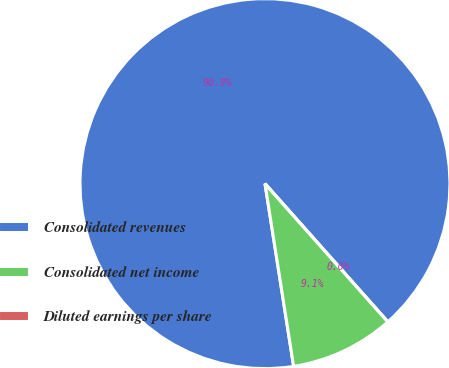<chart> <loc_0><loc_0><loc_500><loc_500><pie_chart><fcel>Consolidated revenues<fcel>Consolidated net income<fcel>Diluted earnings per share<nl><fcel>90.9%<fcel>9.09%<fcel>0.0%<nl></chart> 